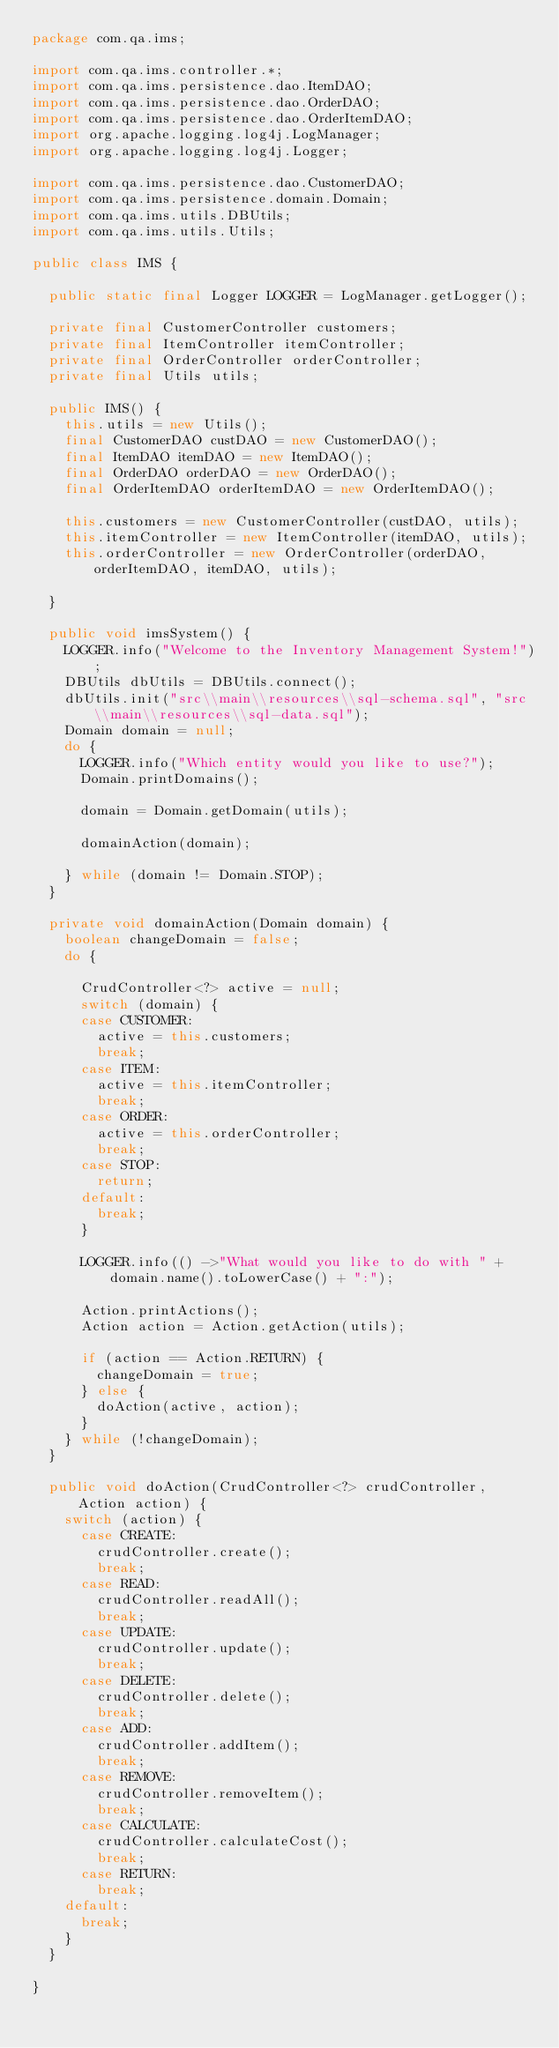Convert code to text. <code><loc_0><loc_0><loc_500><loc_500><_Java_>package com.qa.ims;

import com.qa.ims.controller.*;
import com.qa.ims.persistence.dao.ItemDAO;
import com.qa.ims.persistence.dao.OrderDAO;
import com.qa.ims.persistence.dao.OrderItemDAO;
import org.apache.logging.log4j.LogManager;
import org.apache.logging.log4j.Logger;

import com.qa.ims.persistence.dao.CustomerDAO;
import com.qa.ims.persistence.domain.Domain;
import com.qa.ims.utils.DBUtils;
import com.qa.ims.utils.Utils;

public class IMS {

	public static final Logger LOGGER = LogManager.getLogger();

	private final CustomerController customers;
	private final ItemController itemController;
	private final OrderController orderController;
	private final Utils utils;

	public IMS() {
		this.utils = new Utils();
		final CustomerDAO custDAO = new CustomerDAO();
		final ItemDAO itemDAO = new ItemDAO();
		final OrderDAO orderDAO = new OrderDAO();
		final OrderItemDAO orderItemDAO = new OrderItemDAO();

		this.customers = new CustomerController(custDAO, utils);
		this.itemController = new ItemController(itemDAO, utils);
		this.orderController = new OrderController(orderDAO, orderItemDAO, itemDAO, utils);

	}

	public void imsSystem() {
		LOGGER.info("Welcome to the Inventory Management System!");
		DBUtils dbUtils = DBUtils.connect();
		dbUtils.init("src\\main\\resources\\sql-schema.sql", "src\\main\\resources\\sql-data.sql");
		Domain domain = null;
		do {
			LOGGER.info("Which entity would you like to use?");
			Domain.printDomains();

			domain = Domain.getDomain(utils);

			domainAction(domain);

		} while (domain != Domain.STOP);
	}

	private void domainAction(Domain domain) {
		boolean changeDomain = false;
		do {

			CrudController<?> active = null;
			switch (domain) {
			case CUSTOMER:
				active = this.customers;
				break;
			case ITEM:
				active = this.itemController;
				break;
			case ORDER:
				active = this.orderController;
				break;
			case STOP:
				return;
			default:
				break;
			}

			LOGGER.info(() ->"What would you like to do with " + domain.name().toLowerCase() + ":");

			Action.printActions();
			Action action = Action.getAction(utils);

			if (action == Action.RETURN) {
				changeDomain = true;
			} else {
				doAction(active, action);
			}
		} while (!changeDomain);
	}

	public void doAction(CrudController<?> crudController, Action action) {
		switch (action) {
			case CREATE:
				crudController.create();
				break;
			case READ:
				crudController.readAll();
				break;
			case UPDATE:
				crudController.update();
				break;
			case DELETE:
				crudController.delete();
				break;
			case ADD:
				crudController.addItem();
				break;
			case REMOVE:
				crudController.removeItem();
				break;
			case CALCULATE:
				crudController.calculateCost();
				break;
			case RETURN:
				break;
		default:
			break;
		}
	}

}
</code> 